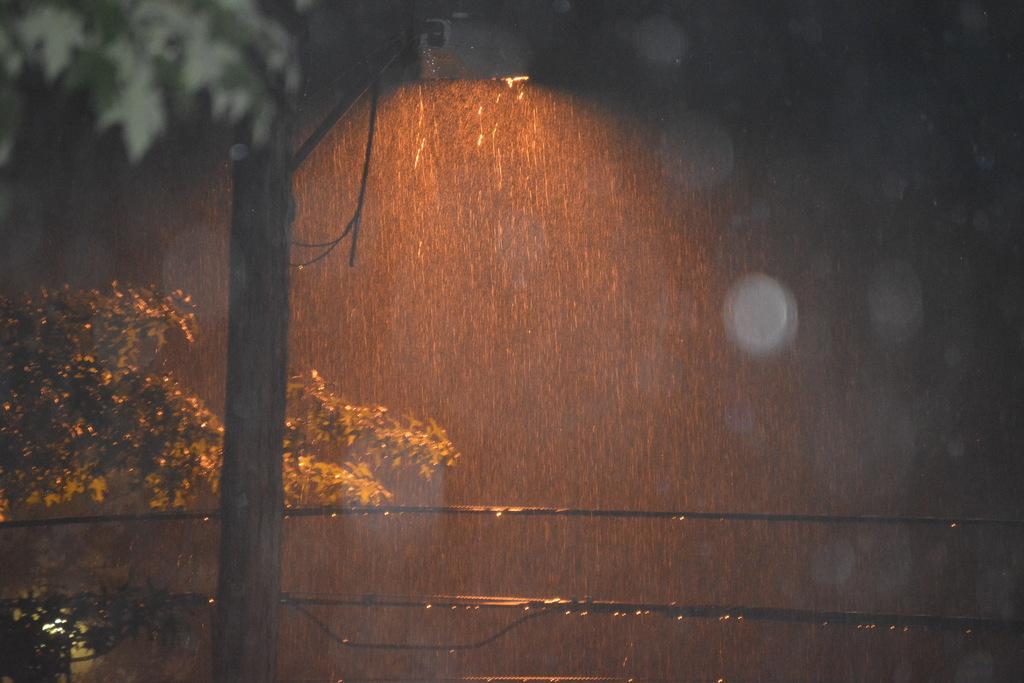Please provide a concise description of this image. In this image I can see trees,wires and it is raining. 